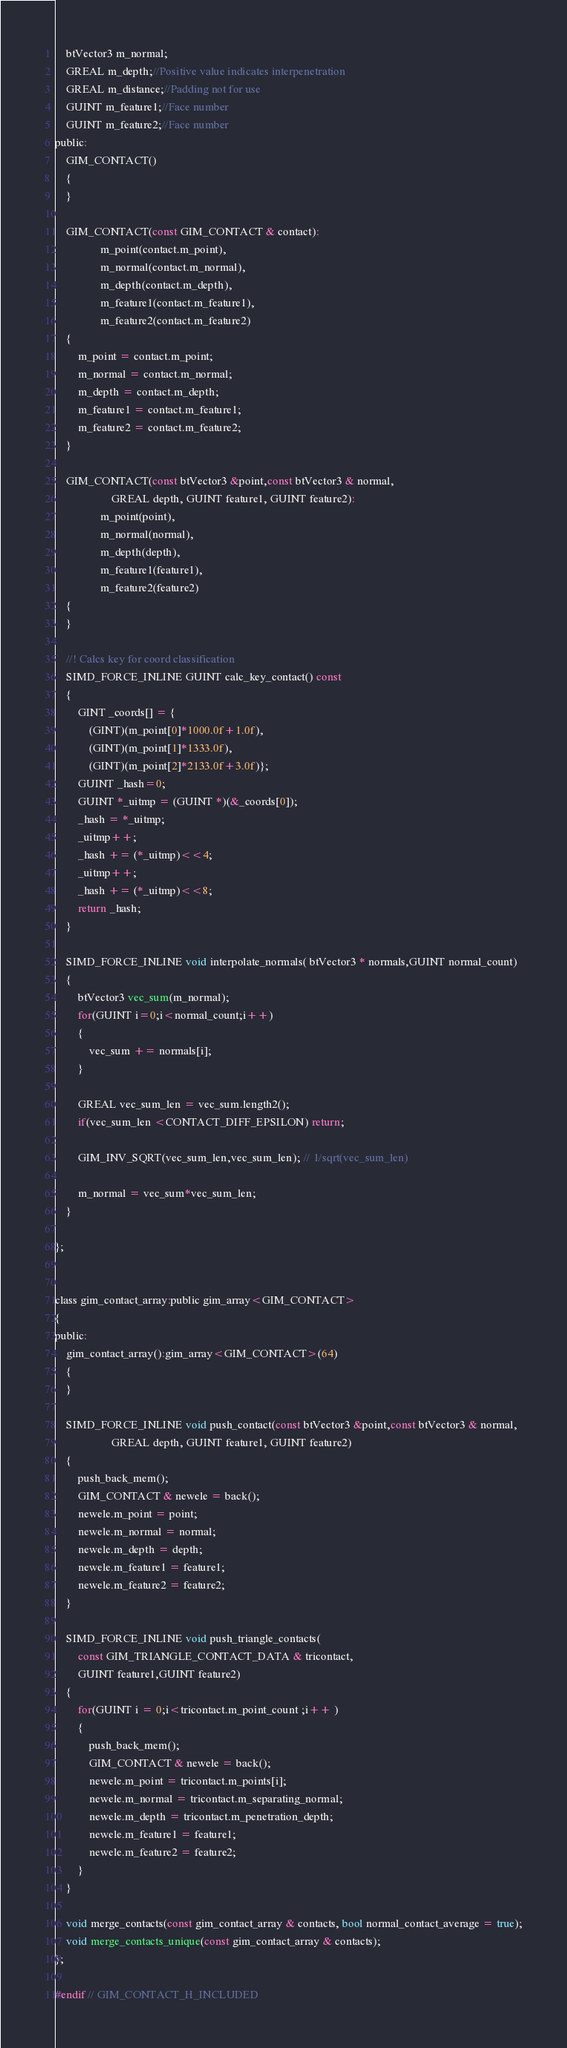Convert code to text. <code><loc_0><loc_0><loc_500><loc_500><_C_>    btVector3 m_normal;
    GREAL m_depth;//Positive value indicates interpenetration
    GREAL m_distance;//Padding not for use
    GUINT m_feature1;//Face number
    GUINT m_feature2;//Face number
public:
    GIM_CONTACT()
    {
    }

    GIM_CONTACT(const GIM_CONTACT & contact):
				m_point(contact.m_point),
				m_normal(contact.m_normal),
				m_depth(contact.m_depth),
				m_feature1(contact.m_feature1),
				m_feature2(contact.m_feature2)
    {
    	m_point = contact.m_point;
    	m_normal = contact.m_normal;
    	m_depth = contact.m_depth;
    	m_feature1 = contact.m_feature1;
    	m_feature2 = contact.m_feature2;
    }

    GIM_CONTACT(const btVector3 &point,const btVector3 & normal,
    	 			GREAL depth, GUINT feature1, GUINT feature2):
				m_point(point),
				m_normal(normal),
				m_depth(depth),
				m_feature1(feature1),
				m_feature2(feature2)
    {
    }

	//! Calcs key for coord classification
    SIMD_FORCE_INLINE GUINT calc_key_contact() const
    {
    	GINT _coords[] = {
    		(GINT)(m_point[0]*1000.0f+1.0f),
    		(GINT)(m_point[1]*1333.0f),
    		(GINT)(m_point[2]*2133.0f+3.0f)};
		GUINT _hash=0;
		GUINT *_uitmp = (GUINT *)(&_coords[0]);
		_hash = *_uitmp;
		_uitmp++;
		_hash += (*_uitmp)<<4;
		_uitmp++;
		_hash += (*_uitmp)<<8;
		return _hash;
    }

    SIMD_FORCE_INLINE void interpolate_normals( btVector3 * normals,GUINT normal_count)
    {
    	btVector3 vec_sum(m_normal);
		for(GUINT i=0;i<normal_count;i++)
		{
			vec_sum += normals[i];
		}

		GREAL vec_sum_len = vec_sum.length2();
		if(vec_sum_len <CONTACT_DIFF_EPSILON) return;

		GIM_INV_SQRT(vec_sum_len,vec_sum_len); // 1/sqrt(vec_sum_len)

		m_normal = vec_sum*vec_sum_len;
    }

};


class gim_contact_array:public gim_array<GIM_CONTACT>
{
public:
	gim_contact_array():gim_array<GIM_CONTACT>(64)
	{
	}

	SIMD_FORCE_INLINE void push_contact(const btVector3 &point,const btVector3 & normal,
    	 			GREAL depth, GUINT feature1, GUINT feature2)
	{
		push_back_mem();
		GIM_CONTACT & newele = back();
		newele.m_point = point;
		newele.m_normal = normal;
		newele.m_depth = depth;
		newele.m_feature1 = feature1;
		newele.m_feature2 = feature2;
	}

	SIMD_FORCE_INLINE void push_triangle_contacts(
		const GIM_TRIANGLE_CONTACT_DATA & tricontact,
		GUINT feature1,GUINT feature2)
	{
		for(GUINT i = 0;i<tricontact.m_point_count ;i++ )
		{
			push_back_mem();
			GIM_CONTACT & newele = back();
			newele.m_point = tricontact.m_points[i];
			newele.m_normal = tricontact.m_separating_normal;
			newele.m_depth = tricontact.m_penetration_depth;
			newele.m_feature1 = feature1;
			newele.m_feature2 = feature2;
		}
	}

	void merge_contacts(const gim_contact_array & contacts, bool normal_contact_average = true);
	void merge_contacts_unique(const gim_contact_array & contacts);
};

#endif // GIM_CONTACT_H_INCLUDED
</code> 